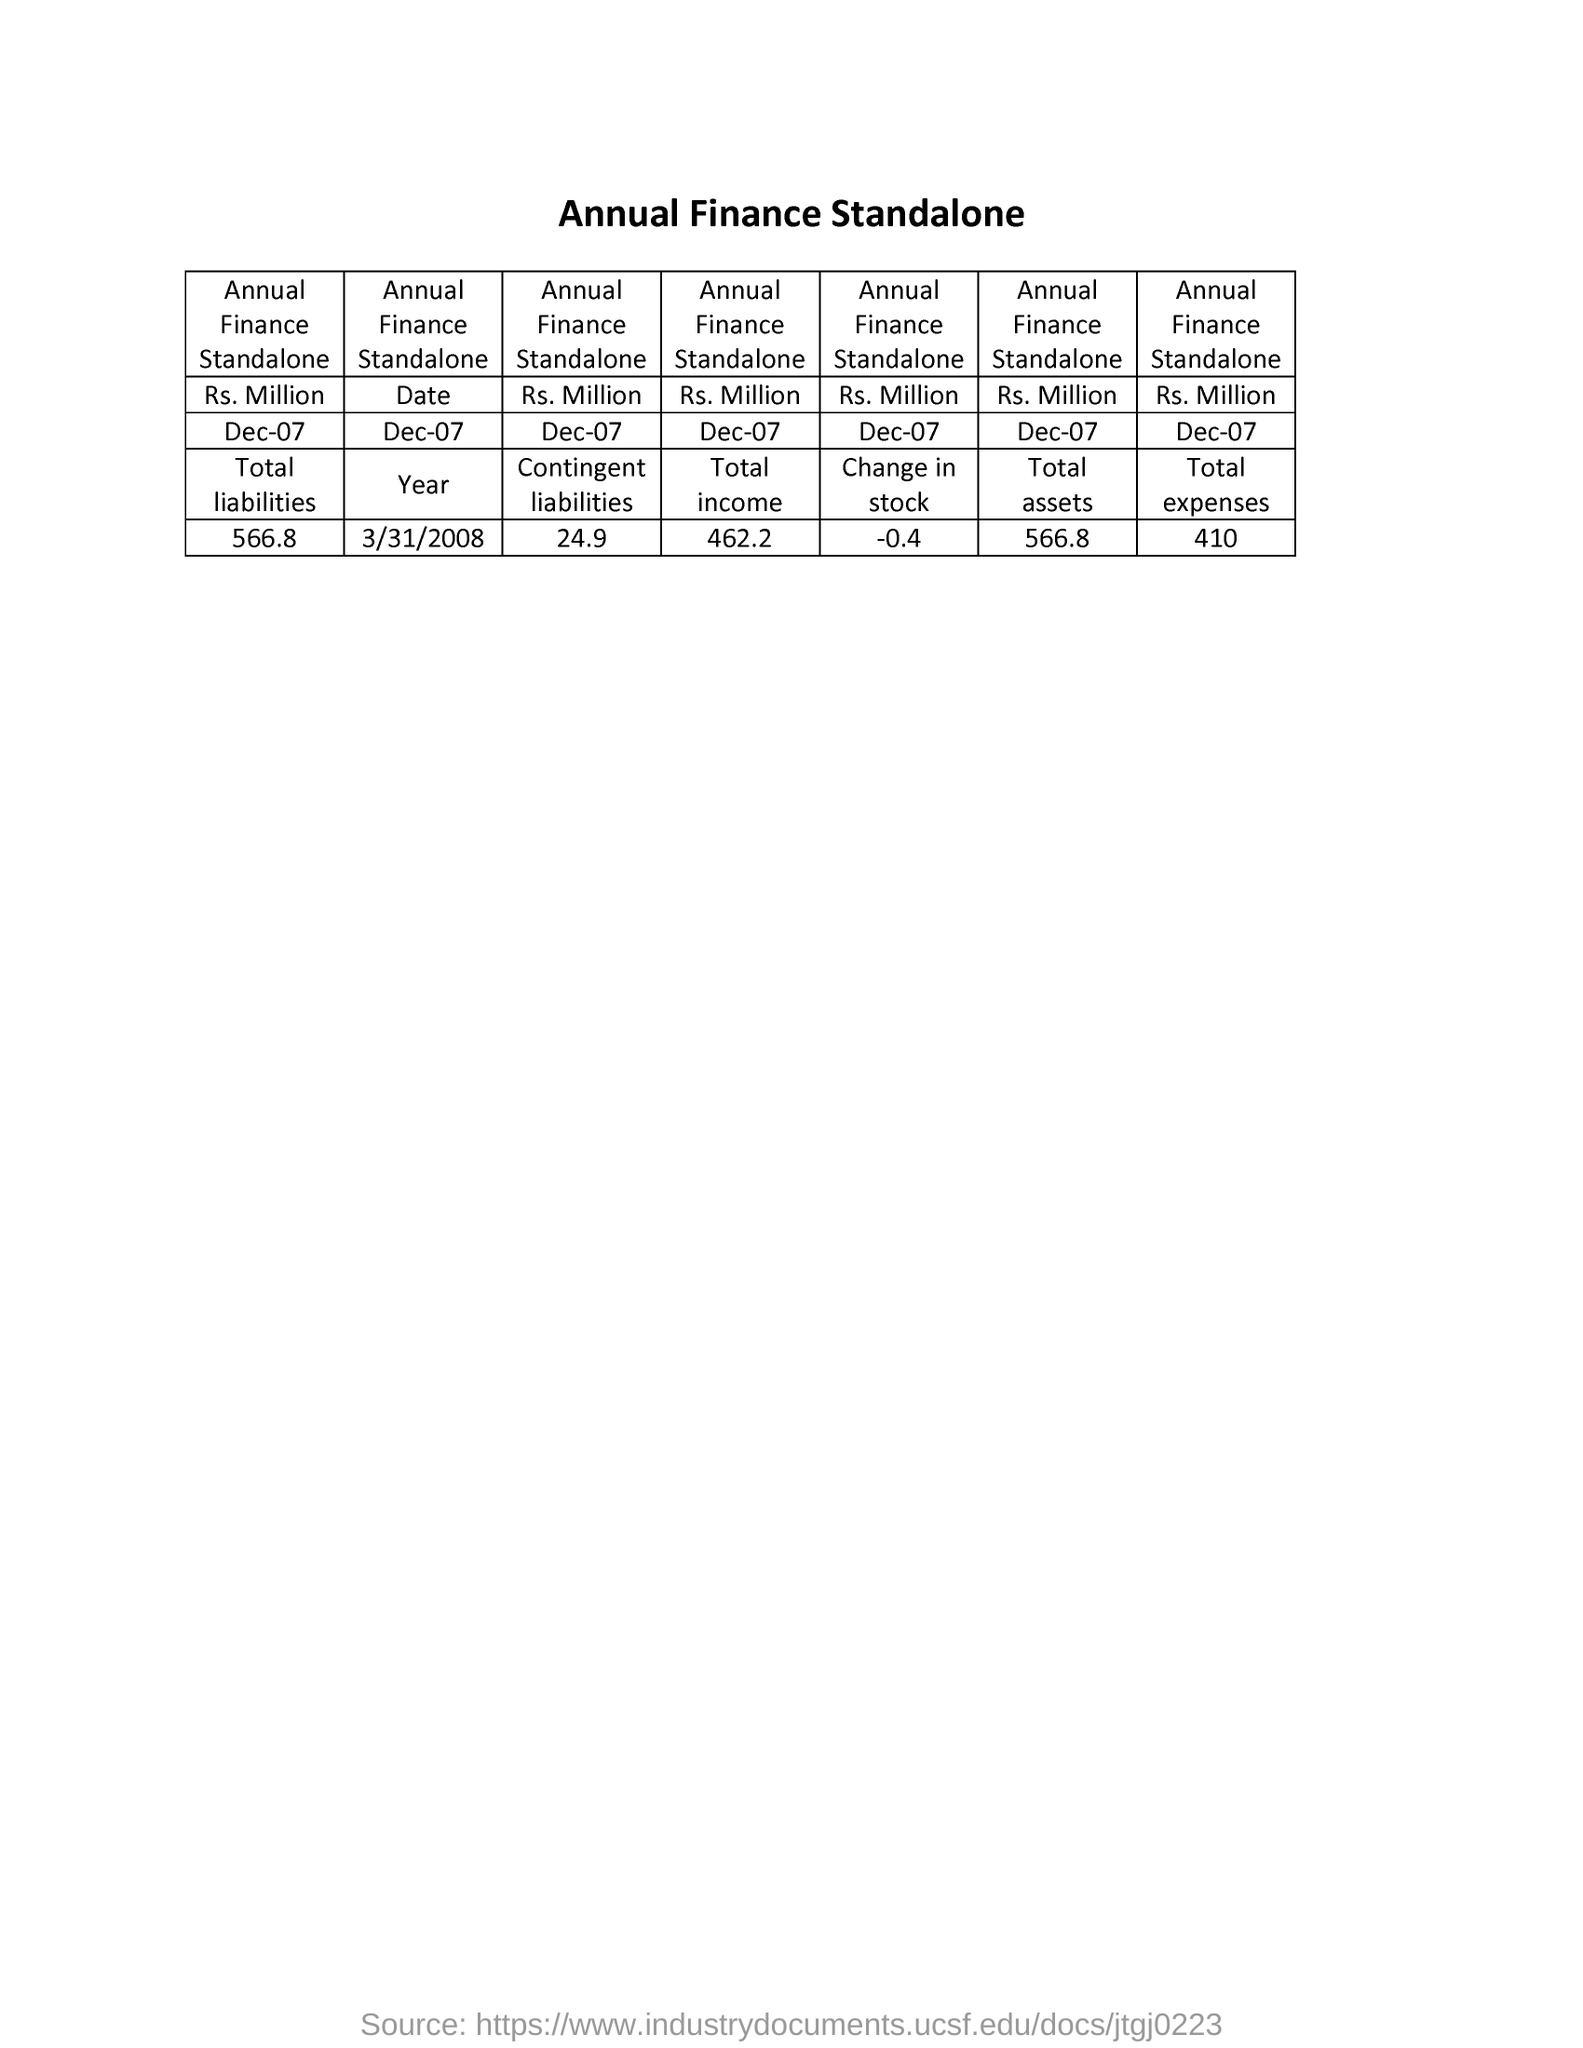Outline some significant characteristics in this image. The total expenses amount to 410. The total liabilities as of December 7th were $566.80. The amount of contingent liabilities is approximately 24.9. The change in stock is -0.4. 